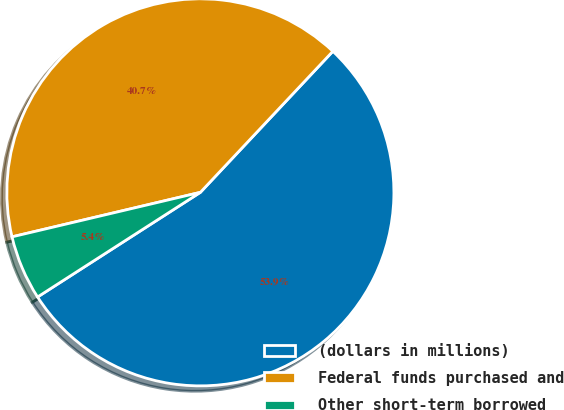Convert chart. <chart><loc_0><loc_0><loc_500><loc_500><pie_chart><fcel>(dollars in millions)<fcel>Federal funds purchased and<fcel>Other short-term borrowed<nl><fcel>53.91%<fcel>40.7%<fcel>5.4%<nl></chart> 